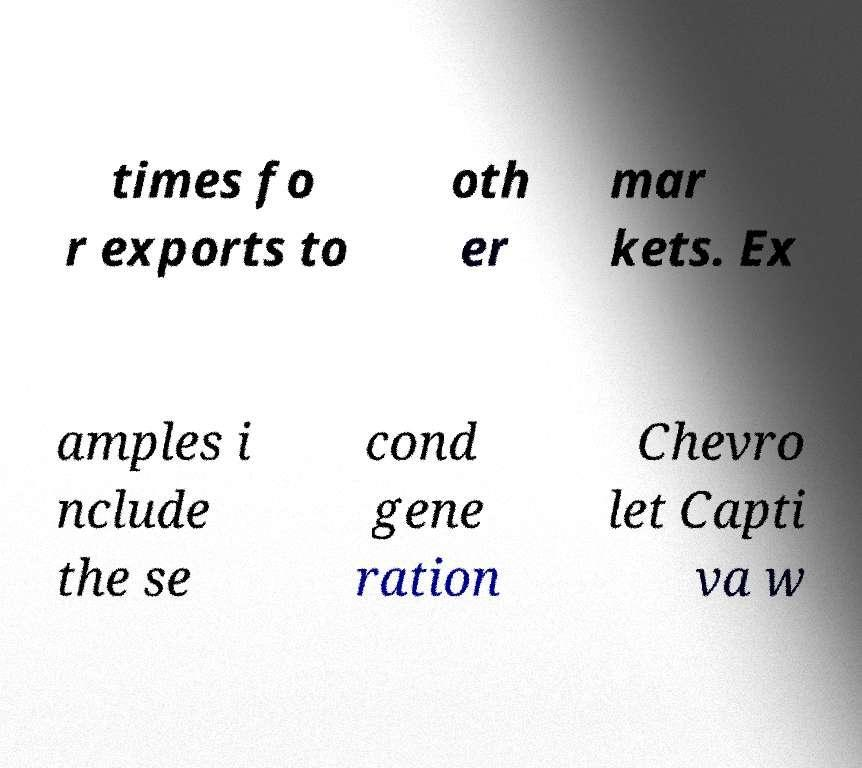Please read and relay the text visible in this image. What does it say? times fo r exports to oth er mar kets. Ex amples i nclude the se cond gene ration Chevro let Capti va w 